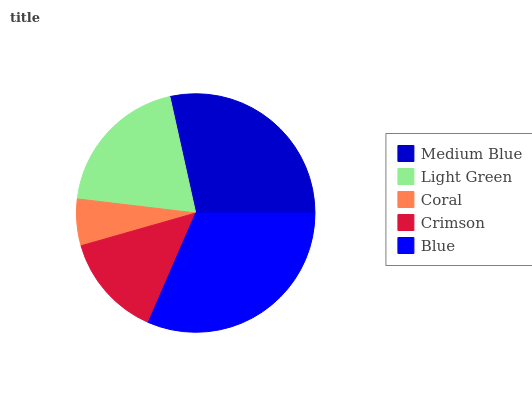Is Coral the minimum?
Answer yes or no. Yes. Is Blue the maximum?
Answer yes or no. Yes. Is Light Green the minimum?
Answer yes or no. No. Is Light Green the maximum?
Answer yes or no. No. Is Medium Blue greater than Light Green?
Answer yes or no. Yes. Is Light Green less than Medium Blue?
Answer yes or no. Yes. Is Light Green greater than Medium Blue?
Answer yes or no. No. Is Medium Blue less than Light Green?
Answer yes or no. No. Is Light Green the high median?
Answer yes or no. Yes. Is Light Green the low median?
Answer yes or no. Yes. Is Medium Blue the high median?
Answer yes or no. No. Is Coral the low median?
Answer yes or no. No. 